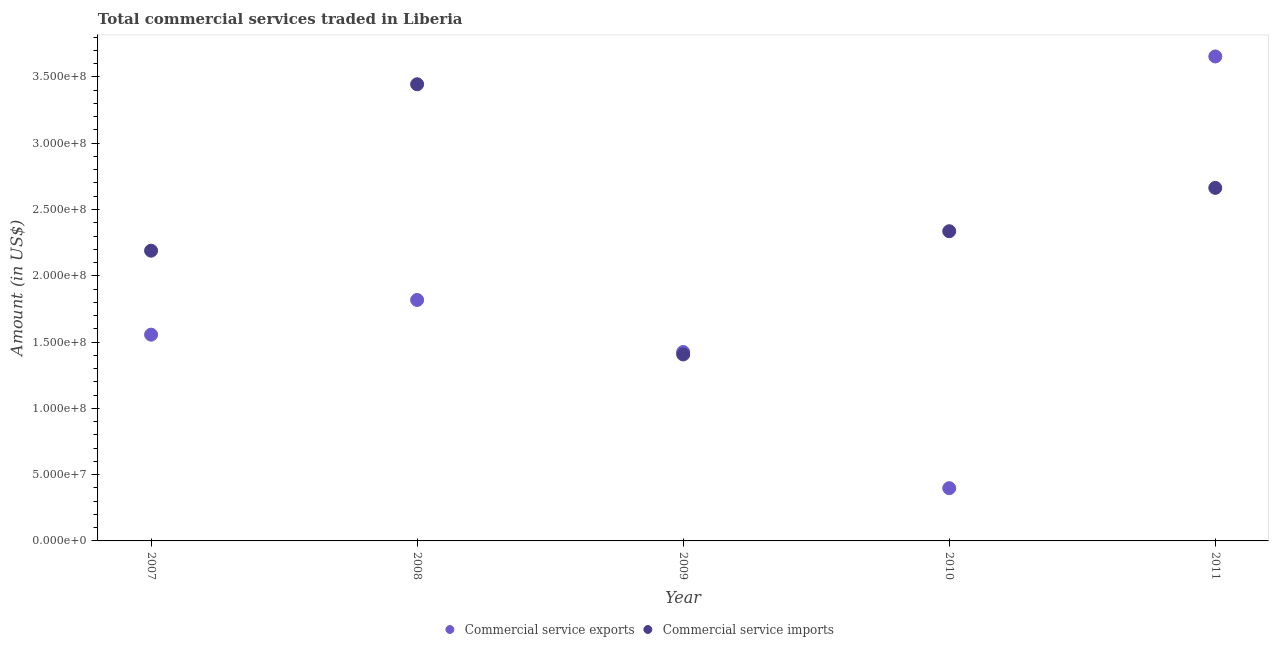Is the number of dotlines equal to the number of legend labels?
Your answer should be very brief. Yes. What is the amount of commercial service imports in 2007?
Give a very brief answer. 2.19e+08. Across all years, what is the maximum amount of commercial service imports?
Make the answer very short. 3.44e+08. Across all years, what is the minimum amount of commercial service exports?
Keep it short and to the point. 3.98e+07. In which year was the amount of commercial service imports minimum?
Offer a terse response. 2009. What is the total amount of commercial service exports in the graph?
Your answer should be compact. 8.85e+08. What is the difference between the amount of commercial service imports in 2007 and that in 2011?
Provide a short and direct response. -4.74e+07. What is the difference between the amount of commercial service imports in 2007 and the amount of commercial service exports in 2008?
Your answer should be very brief. 3.72e+07. What is the average amount of commercial service imports per year?
Keep it short and to the point. 2.41e+08. In the year 2009, what is the difference between the amount of commercial service exports and amount of commercial service imports?
Ensure brevity in your answer.  1.81e+06. What is the ratio of the amount of commercial service imports in 2008 to that in 2011?
Provide a succinct answer. 1.29. Is the amount of commercial service exports in 2008 less than that in 2010?
Offer a very short reply. No. What is the difference between the highest and the second highest amount of commercial service imports?
Ensure brevity in your answer.  7.82e+07. What is the difference between the highest and the lowest amount of commercial service exports?
Make the answer very short. 3.26e+08. In how many years, is the amount of commercial service exports greater than the average amount of commercial service exports taken over all years?
Provide a succinct answer. 2. Is the sum of the amount of commercial service imports in 2008 and 2010 greater than the maximum amount of commercial service exports across all years?
Offer a terse response. Yes. Does the amount of commercial service imports monotonically increase over the years?
Offer a terse response. No. Is the amount of commercial service exports strictly greater than the amount of commercial service imports over the years?
Offer a very short reply. No. Is the amount of commercial service exports strictly less than the amount of commercial service imports over the years?
Provide a succinct answer. No. How many dotlines are there?
Give a very brief answer. 2. What is the difference between two consecutive major ticks on the Y-axis?
Your answer should be compact. 5.00e+07. Are the values on the major ticks of Y-axis written in scientific E-notation?
Make the answer very short. Yes. Does the graph contain any zero values?
Make the answer very short. No. Does the graph contain grids?
Your response must be concise. No. Where does the legend appear in the graph?
Make the answer very short. Bottom center. How are the legend labels stacked?
Offer a terse response. Horizontal. What is the title of the graph?
Provide a succinct answer. Total commercial services traded in Liberia. What is the Amount (in US$) in Commercial service exports in 2007?
Offer a very short reply. 1.56e+08. What is the Amount (in US$) of Commercial service imports in 2007?
Ensure brevity in your answer.  2.19e+08. What is the Amount (in US$) of Commercial service exports in 2008?
Offer a terse response. 1.82e+08. What is the Amount (in US$) of Commercial service imports in 2008?
Your answer should be very brief. 3.44e+08. What is the Amount (in US$) in Commercial service exports in 2009?
Your answer should be very brief. 1.42e+08. What is the Amount (in US$) of Commercial service imports in 2009?
Provide a short and direct response. 1.41e+08. What is the Amount (in US$) in Commercial service exports in 2010?
Your answer should be very brief. 3.98e+07. What is the Amount (in US$) in Commercial service imports in 2010?
Your answer should be very brief. 2.34e+08. What is the Amount (in US$) in Commercial service exports in 2011?
Your response must be concise. 3.65e+08. What is the Amount (in US$) in Commercial service imports in 2011?
Your answer should be compact. 2.66e+08. Across all years, what is the maximum Amount (in US$) in Commercial service exports?
Offer a very short reply. 3.65e+08. Across all years, what is the maximum Amount (in US$) of Commercial service imports?
Your response must be concise. 3.44e+08. Across all years, what is the minimum Amount (in US$) of Commercial service exports?
Make the answer very short. 3.98e+07. Across all years, what is the minimum Amount (in US$) of Commercial service imports?
Your response must be concise. 1.41e+08. What is the total Amount (in US$) in Commercial service exports in the graph?
Ensure brevity in your answer.  8.85e+08. What is the total Amount (in US$) of Commercial service imports in the graph?
Keep it short and to the point. 1.20e+09. What is the difference between the Amount (in US$) in Commercial service exports in 2007 and that in 2008?
Your response must be concise. -2.62e+07. What is the difference between the Amount (in US$) in Commercial service imports in 2007 and that in 2008?
Keep it short and to the point. -1.26e+08. What is the difference between the Amount (in US$) in Commercial service exports in 2007 and that in 2009?
Provide a succinct answer. 1.31e+07. What is the difference between the Amount (in US$) in Commercial service imports in 2007 and that in 2009?
Ensure brevity in your answer.  7.83e+07. What is the difference between the Amount (in US$) in Commercial service exports in 2007 and that in 2010?
Provide a succinct answer. 1.16e+08. What is the difference between the Amount (in US$) of Commercial service imports in 2007 and that in 2010?
Make the answer very short. -1.47e+07. What is the difference between the Amount (in US$) of Commercial service exports in 2007 and that in 2011?
Your answer should be compact. -2.10e+08. What is the difference between the Amount (in US$) of Commercial service imports in 2007 and that in 2011?
Make the answer very short. -4.74e+07. What is the difference between the Amount (in US$) in Commercial service exports in 2008 and that in 2009?
Offer a terse response. 3.93e+07. What is the difference between the Amount (in US$) of Commercial service imports in 2008 and that in 2009?
Make the answer very short. 2.04e+08. What is the difference between the Amount (in US$) of Commercial service exports in 2008 and that in 2010?
Ensure brevity in your answer.  1.42e+08. What is the difference between the Amount (in US$) of Commercial service imports in 2008 and that in 2010?
Offer a very short reply. 1.11e+08. What is the difference between the Amount (in US$) in Commercial service exports in 2008 and that in 2011?
Provide a short and direct response. -1.84e+08. What is the difference between the Amount (in US$) in Commercial service imports in 2008 and that in 2011?
Offer a very short reply. 7.82e+07. What is the difference between the Amount (in US$) in Commercial service exports in 2009 and that in 2010?
Offer a very short reply. 1.03e+08. What is the difference between the Amount (in US$) in Commercial service imports in 2009 and that in 2010?
Offer a very short reply. -9.29e+07. What is the difference between the Amount (in US$) in Commercial service exports in 2009 and that in 2011?
Offer a terse response. -2.23e+08. What is the difference between the Amount (in US$) in Commercial service imports in 2009 and that in 2011?
Offer a terse response. -1.26e+08. What is the difference between the Amount (in US$) of Commercial service exports in 2010 and that in 2011?
Your answer should be very brief. -3.26e+08. What is the difference between the Amount (in US$) in Commercial service imports in 2010 and that in 2011?
Your response must be concise. -3.27e+07. What is the difference between the Amount (in US$) in Commercial service exports in 2007 and the Amount (in US$) in Commercial service imports in 2008?
Your response must be concise. -1.89e+08. What is the difference between the Amount (in US$) in Commercial service exports in 2007 and the Amount (in US$) in Commercial service imports in 2009?
Keep it short and to the point. 1.49e+07. What is the difference between the Amount (in US$) in Commercial service exports in 2007 and the Amount (in US$) in Commercial service imports in 2010?
Give a very brief answer. -7.80e+07. What is the difference between the Amount (in US$) in Commercial service exports in 2007 and the Amount (in US$) in Commercial service imports in 2011?
Give a very brief answer. -1.11e+08. What is the difference between the Amount (in US$) in Commercial service exports in 2008 and the Amount (in US$) in Commercial service imports in 2009?
Your answer should be compact. 4.11e+07. What is the difference between the Amount (in US$) of Commercial service exports in 2008 and the Amount (in US$) of Commercial service imports in 2010?
Your answer should be compact. -5.19e+07. What is the difference between the Amount (in US$) in Commercial service exports in 2008 and the Amount (in US$) in Commercial service imports in 2011?
Keep it short and to the point. -8.46e+07. What is the difference between the Amount (in US$) in Commercial service exports in 2009 and the Amount (in US$) in Commercial service imports in 2010?
Provide a succinct answer. -9.11e+07. What is the difference between the Amount (in US$) in Commercial service exports in 2009 and the Amount (in US$) in Commercial service imports in 2011?
Offer a very short reply. -1.24e+08. What is the difference between the Amount (in US$) in Commercial service exports in 2010 and the Amount (in US$) in Commercial service imports in 2011?
Ensure brevity in your answer.  -2.27e+08. What is the average Amount (in US$) in Commercial service exports per year?
Provide a succinct answer. 1.77e+08. What is the average Amount (in US$) of Commercial service imports per year?
Your answer should be compact. 2.41e+08. In the year 2007, what is the difference between the Amount (in US$) of Commercial service exports and Amount (in US$) of Commercial service imports?
Keep it short and to the point. -6.33e+07. In the year 2008, what is the difference between the Amount (in US$) in Commercial service exports and Amount (in US$) in Commercial service imports?
Your answer should be compact. -1.63e+08. In the year 2009, what is the difference between the Amount (in US$) of Commercial service exports and Amount (in US$) of Commercial service imports?
Make the answer very short. 1.81e+06. In the year 2010, what is the difference between the Amount (in US$) of Commercial service exports and Amount (in US$) of Commercial service imports?
Provide a short and direct response. -1.94e+08. In the year 2011, what is the difference between the Amount (in US$) in Commercial service exports and Amount (in US$) in Commercial service imports?
Provide a short and direct response. 9.91e+07. What is the ratio of the Amount (in US$) in Commercial service exports in 2007 to that in 2008?
Your answer should be very brief. 0.86. What is the ratio of the Amount (in US$) in Commercial service imports in 2007 to that in 2008?
Offer a very short reply. 0.64. What is the ratio of the Amount (in US$) of Commercial service exports in 2007 to that in 2009?
Offer a very short reply. 1.09. What is the ratio of the Amount (in US$) in Commercial service imports in 2007 to that in 2009?
Your answer should be very brief. 1.56. What is the ratio of the Amount (in US$) in Commercial service exports in 2007 to that in 2010?
Ensure brevity in your answer.  3.91. What is the ratio of the Amount (in US$) of Commercial service imports in 2007 to that in 2010?
Your response must be concise. 0.94. What is the ratio of the Amount (in US$) of Commercial service exports in 2007 to that in 2011?
Provide a short and direct response. 0.43. What is the ratio of the Amount (in US$) in Commercial service imports in 2007 to that in 2011?
Ensure brevity in your answer.  0.82. What is the ratio of the Amount (in US$) in Commercial service exports in 2008 to that in 2009?
Ensure brevity in your answer.  1.28. What is the ratio of the Amount (in US$) of Commercial service imports in 2008 to that in 2009?
Keep it short and to the point. 2.45. What is the ratio of the Amount (in US$) in Commercial service exports in 2008 to that in 2010?
Your response must be concise. 4.57. What is the ratio of the Amount (in US$) in Commercial service imports in 2008 to that in 2010?
Provide a short and direct response. 1.47. What is the ratio of the Amount (in US$) of Commercial service exports in 2008 to that in 2011?
Provide a short and direct response. 0.5. What is the ratio of the Amount (in US$) in Commercial service imports in 2008 to that in 2011?
Offer a terse response. 1.29. What is the ratio of the Amount (in US$) of Commercial service exports in 2009 to that in 2010?
Offer a very short reply. 3.58. What is the ratio of the Amount (in US$) of Commercial service imports in 2009 to that in 2010?
Your response must be concise. 0.6. What is the ratio of the Amount (in US$) of Commercial service exports in 2009 to that in 2011?
Your response must be concise. 0.39. What is the ratio of the Amount (in US$) of Commercial service imports in 2009 to that in 2011?
Your response must be concise. 0.53. What is the ratio of the Amount (in US$) in Commercial service exports in 2010 to that in 2011?
Ensure brevity in your answer.  0.11. What is the ratio of the Amount (in US$) in Commercial service imports in 2010 to that in 2011?
Your response must be concise. 0.88. What is the difference between the highest and the second highest Amount (in US$) in Commercial service exports?
Keep it short and to the point. 1.84e+08. What is the difference between the highest and the second highest Amount (in US$) in Commercial service imports?
Keep it short and to the point. 7.82e+07. What is the difference between the highest and the lowest Amount (in US$) of Commercial service exports?
Ensure brevity in your answer.  3.26e+08. What is the difference between the highest and the lowest Amount (in US$) of Commercial service imports?
Your answer should be compact. 2.04e+08. 